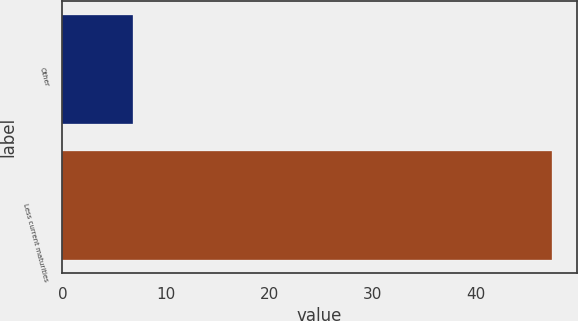Convert chart to OTSL. <chart><loc_0><loc_0><loc_500><loc_500><bar_chart><fcel>Other<fcel>Less current maturities<nl><fcel>6.8<fcel>47.4<nl></chart> 